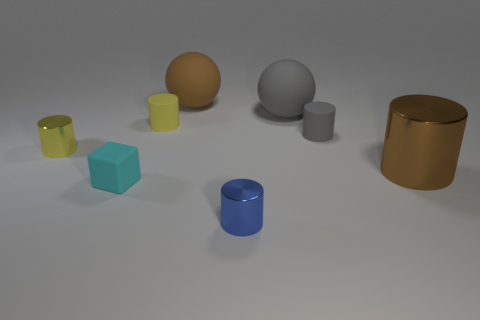The brown object that is the same shape as the small yellow metal thing is what size?
Your answer should be very brief. Large. There is a brown cylinder; are there any large rubber balls on the left side of it?
Provide a succinct answer. Yes. What material is the brown ball?
Keep it short and to the point. Rubber. Does the large rubber object behind the gray matte ball have the same color as the small rubber block?
Give a very brief answer. No. Are there any other things that are the same shape as the big brown matte object?
Make the answer very short. Yes. What is the color of the other tiny matte object that is the same shape as the small gray thing?
Your response must be concise. Yellow. There is a tiny yellow thing that is right of the tiny rubber cube; what is it made of?
Offer a terse response. Rubber. The big shiny object is what color?
Offer a terse response. Brown. Does the cylinder in front of the brown cylinder have the same size as the gray matte cylinder?
Your response must be concise. Yes. What is the ball to the right of the matte sphere that is behind the big ball right of the brown rubber object made of?
Your answer should be compact. Rubber. 